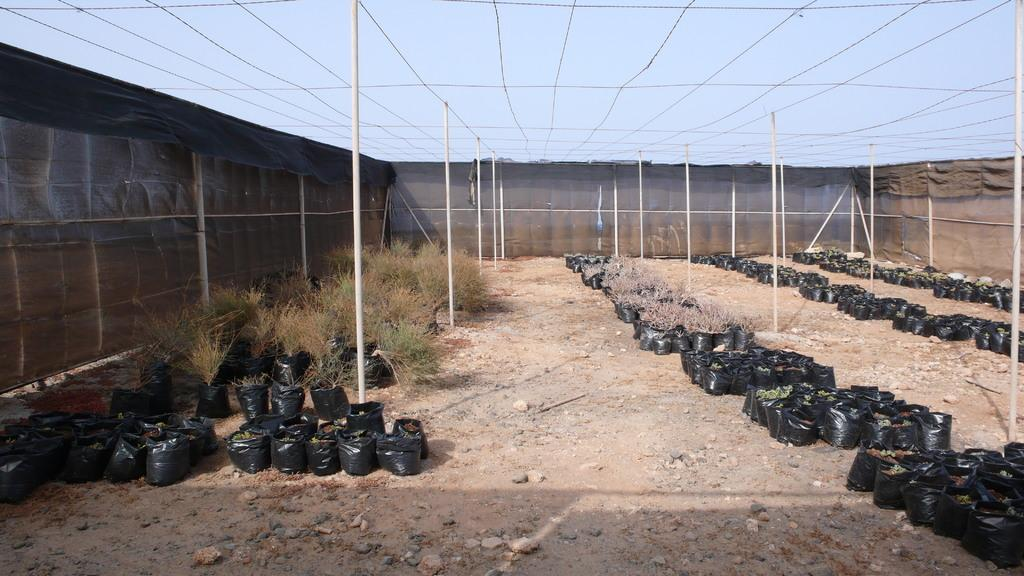What is located in the center of the image? There are plants placed in poly bags in the center of the image. What else can be seen in the image besides the plants? There are poles in the image. What is visible at the top of the image? The sky is visible at the top of the image. What type of barrier is present in the image? There is a fence in the image. How does the hose turn the plants in the image? There is no hose present in the image, so it cannot turn the plants. 